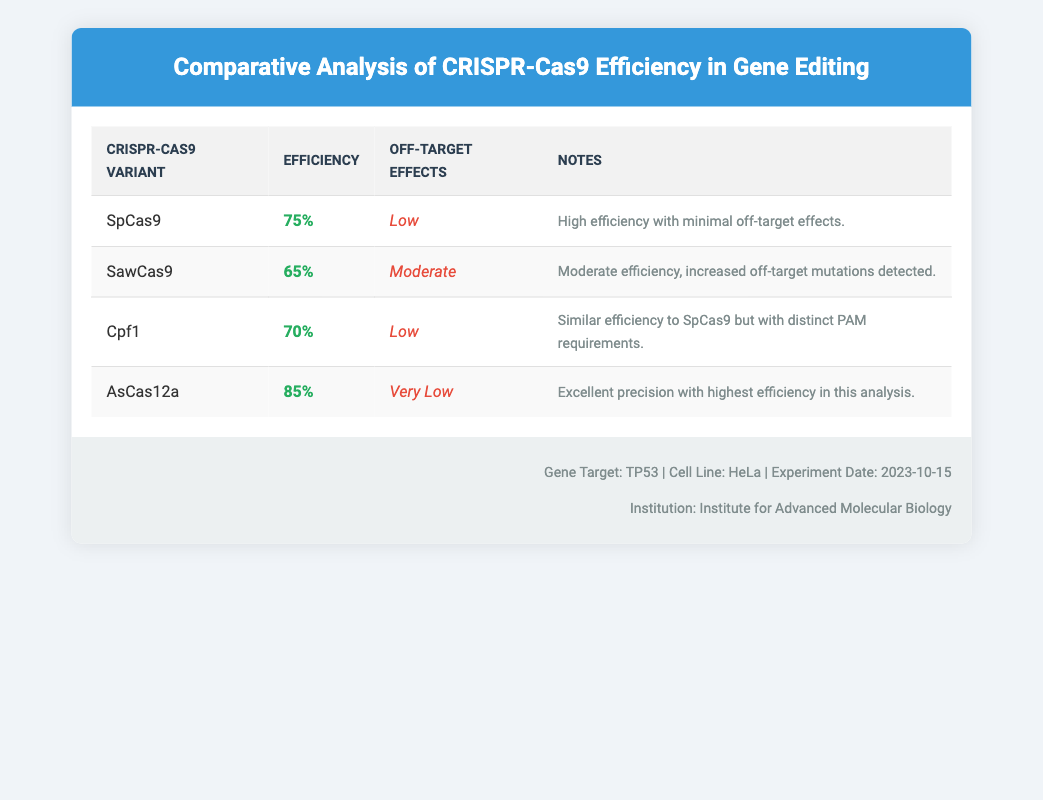What is the efficiency of the SpCas9 variant? According to the table, the efficiency of the SpCas9 variant is listed as 75%.
Answer: 75% Which CRISPR-Cas9 variant has the lowest efficiency? Among the variants listed, SawCas9 has the lowest efficiency at 65%.
Answer: SawCas9 Is the off-target effect of AsCas12a low? The table indicates that the off-target effect of AsCas12a is categorized as "Very Low," confirming that it has low off-target effects.
Answer: Yes What is the difference in efficiency between AsCas12a and Cpf1? AsCas12a has an efficiency of 85%, while Cpf1 has an efficiency of 70%. The difference can be calculated as 85% - 70% = 15%.
Answer: 15% Which variant has a moderate off-target effect? The SawCas9 variant is noted to have a moderate off-target effect.
Answer: SawCas9 Calculate the average efficiency of the CRISPR-Cas9 variants in the study. To find the average, add the efficiencies of all variants: 75% + 65% + 70% + 85% = 295%. Then divide by the number of variants (4): 295% / 4 = 73.75%.
Answer: 73.75% Are there any variants listed with high efficiency and low off-target effects? Yes, both SpCas9 and Cpf1 are noted to have high efficiency with low off-target effects.
Answer: Yes What are the potential off-target effects associated with Cpf1? The table indicates that Cpf1 has low off-target effects, specifically stating "Low."
Answer: Low Which variant exhibits the highest efficiency in this analysis? The analysis shows that AsCas12a has the highest efficiency at 85%.
Answer: AsCas12a 